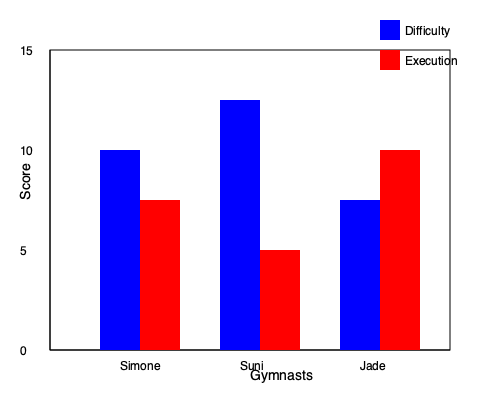Based on the bar chart comparing difficulty and execution scores for three gymnasts, which gymnast has the highest total score, and what is the difference between their difficulty and execution scores? To solve this question, we need to follow these steps:

1. Identify the difficulty (blue) and execution (red) scores for each gymnast:
   Simone: Difficulty = 10, Execution = 7.5
   Suni: Difficulty = 12.5, Execution = 5
   Jade: Difficulty = 7.5, Execution = 10

2. Calculate the total score for each gymnast by adding their difficulty and execution scores:
   Simone: 10 + 7.5 = 17.5
   Suni: 12.5 + 5 = 17.5
   Jade: 7.5 + 10 = 17.5

3. Determine the gymnast with the highest total score:
   All three gymnasts have the same total score of 17.5, so there is no single highest scorer.

4. Calculate the difference between difficulty and execution scores for each gymnast:
   Simone: 10 - 7.5 = 2.5
   Suni: 12.5 - 5 = 7.5
   Jade: 7.5 - 10 = -2.5

5. Identify the gymnast with the largest difference between difficulty and execution scores:
   Suni has the largest difference of 7.5 points.

Therefore, while all gymnasts have the same total score, Suni has the largest difference between her difficulty and execution scores.
Answer: All gymnasts tie for highest score; Suni has largest D-E difference (7.5 points) 